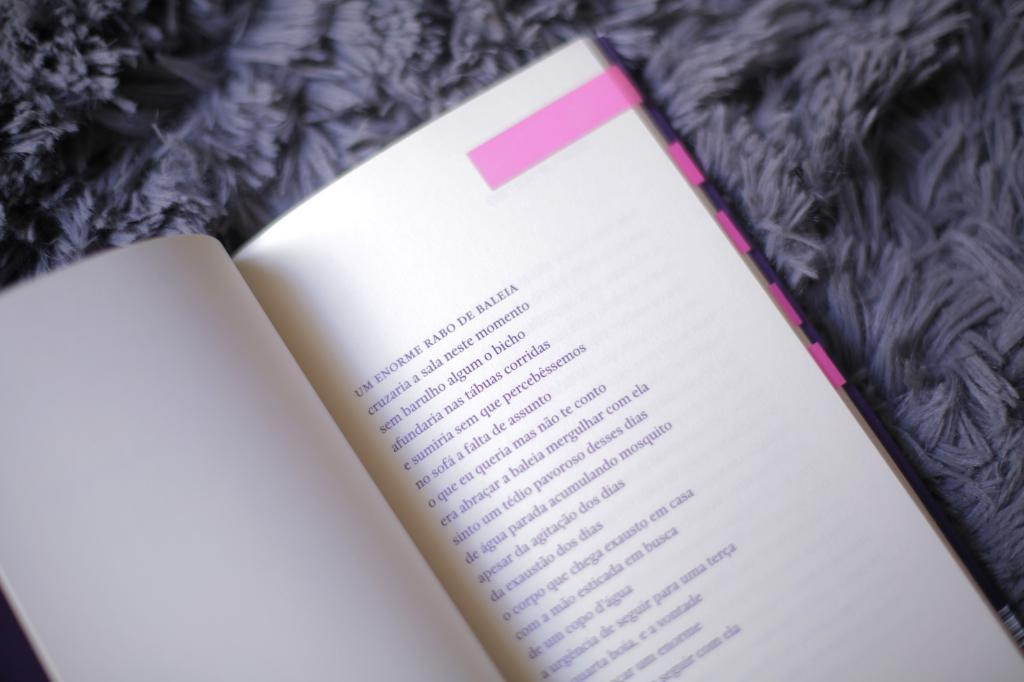<image>
Relay a brief, clear account of the picture shown. a book with the word BALEIA at the end of the first line 